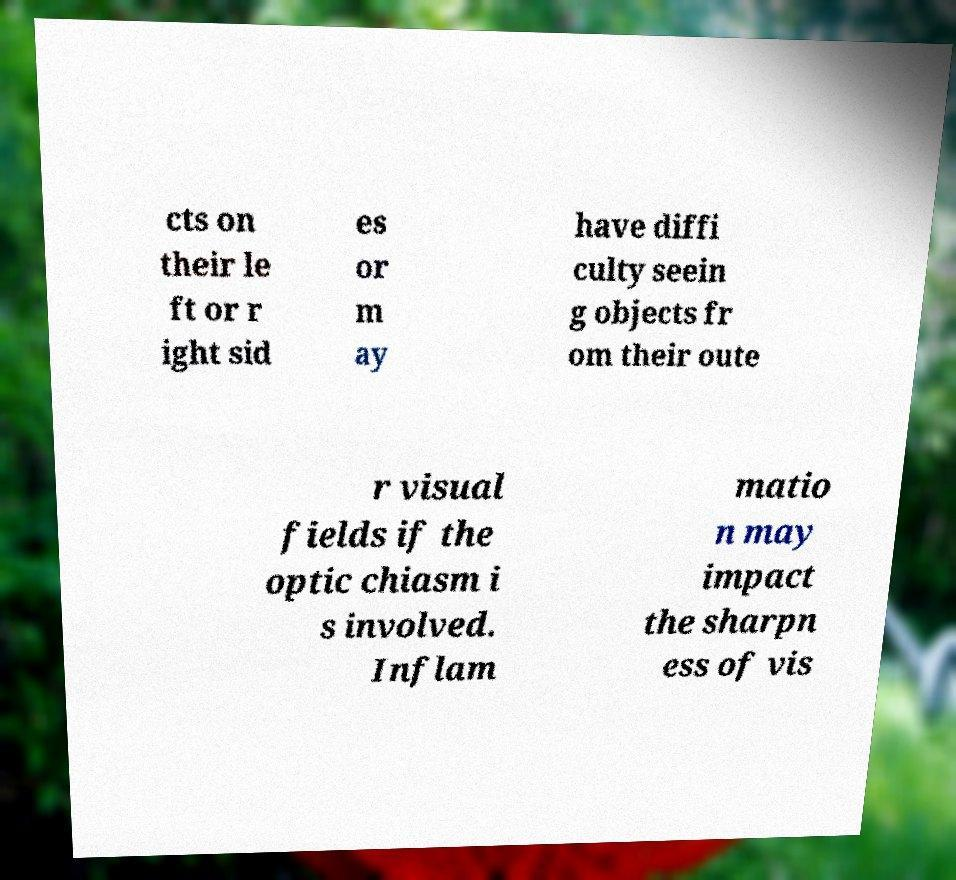What messages or text are displayed in this image? I need them in a readable, typed format. cts on their le ft or r ight sid es or m ay have diffi culty seein g objects fr om their oute r visual fields if the optic chiasm i s involved. Inflam matio n may impact the sharpn ess of vis 